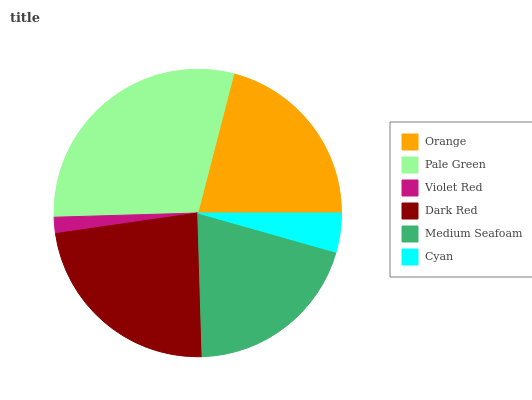Is Violet Red the minimum?
Answer yes or no. Yes. Is Pale Green the maximum?
Answer yes or no. Yes. Is Pale Green the minimum?
Answer yes or no. No. Is Violet Red the maximum?
Answer yes or no. No. Is Pale Green greater than Violet Red?
Answer yes or no. Yes. Is Violet Red less than Pale Green?
Answer yes or no. Yes. Is Violet Red greater than Pale Green?
Answer yes or no. No. Is Pale Green less than Violet Red?
Answer yes or no. No. Is Orange the high median?
Answer yes or no. Yes. Is Medium Seafoam the low median?
Answer yes or no. Yes. Is Medium Seafoam the high median?
Answer yes or no. No. Is Dark Red the low median?
Answer yes or no. No. 